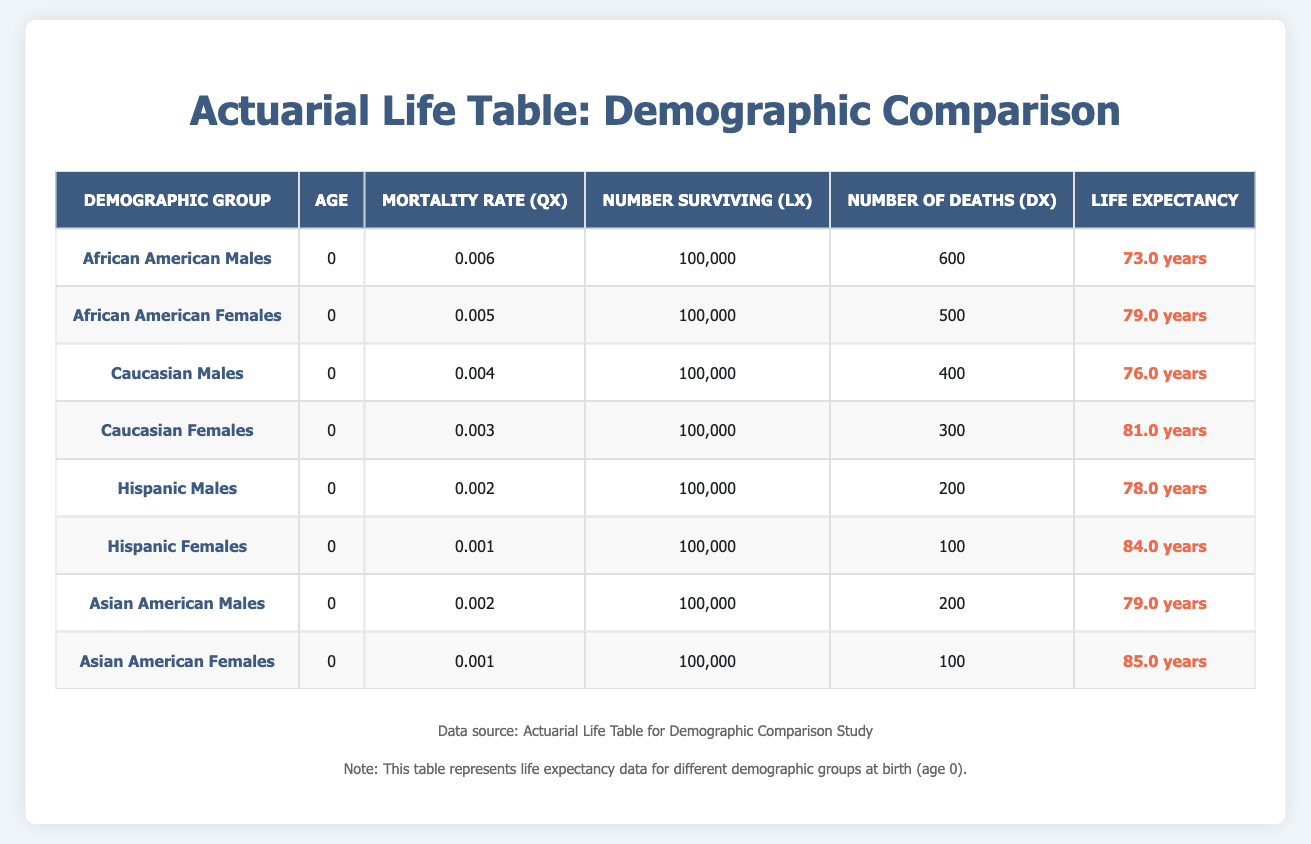What is the life expectancy for Hispanic females? From the table, we can see that the row for Hispanic Females states a life expectancy of 84.0 years.
Answer: 84.0 years Which demographic group has the highest life expectancy? After reviewing the life expectancy values in the table, Hispanic Females have the highest life expectancy at 84.0 years, the next highest being Asian American Females with 85.0 years. Comparing these two, Hispanic Females ranks first.
Answer: Hispanic Females How many deaths (dx) are recorded for Caucasian Males? Looking at the table under the row for Caucasian Males, the number of deaths (dx) is recorded as 400.
Answer: 400 What is the difference in life expectancy between Asian American Females and African American Males? The life expectancy for Asian American Females is 85.0 years and for African American Males is 73.0 years. The difference is 85.0 - 73.0 = 12.0 years.
Answer: 12.0 years Is the mortality rate (qx) for Hispanic Males higher than that for Caucasian Females? The mortality rate for Hispanic Males is 0.002, and for Caucasian Females it is 0.003. Comparing these two values, 0.002 is less than 0.003, hence the statement is false.
Answer: No What is the average life expectancy of males across all demographic groups? The life expectancies for males in the table are: 73.0 (African American), 76.0 (Caucasian), 78.0 (Hispanic), and 79.0 (Asian American). Adding these gives us a total of 306.0 years. Since there are 4 groups, we find the average by dividing by 4, resulting in 306.0 / 4 = 76.5 years.
Answer: 76.5 years Which demographic group has the lowest mortality rate (qx)? In the table, the lowest qx is listed under Hispanic Females, which is 0.001. Comparing all entries, this is the smallest figure.
Answer: Hispanic Females What is the sum of the number of deaths (dx) for all female demographic groups? The number of deaths for African American Females is 500, Caucasian Females is 300, Hispanic Females is 100, and Asian American Females is 100. Adding these gives: 500 + 300 + 100 + 100 = 1000.
Answer: 1000 